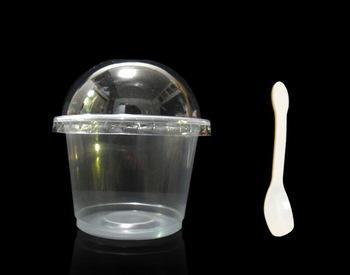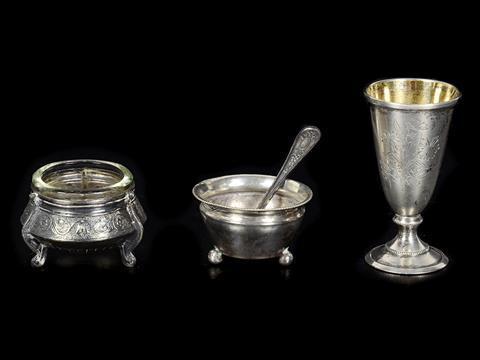The first image is the image on the left, the second image is the image on the right. For the images shown, is this caption "The left image shows a cylindrical glass with liquid and a stirring spoon inside." true? Answer yes or no. No. 